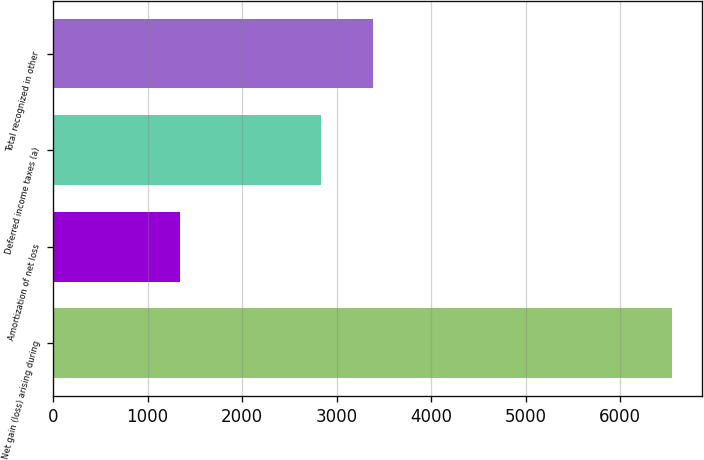Convert chart. <chart><loc_0><loc_0><loc_500><loc_500><bar_chart><fcel>Net gain (loss) arising during<fcel>Amortization of net loss<fcel>Deferred income taxes (a)<fcel>Total recognized in other<nl><fcel>6545<fcel>1338<fcel>2831<fcel>3390<nl></chart> 